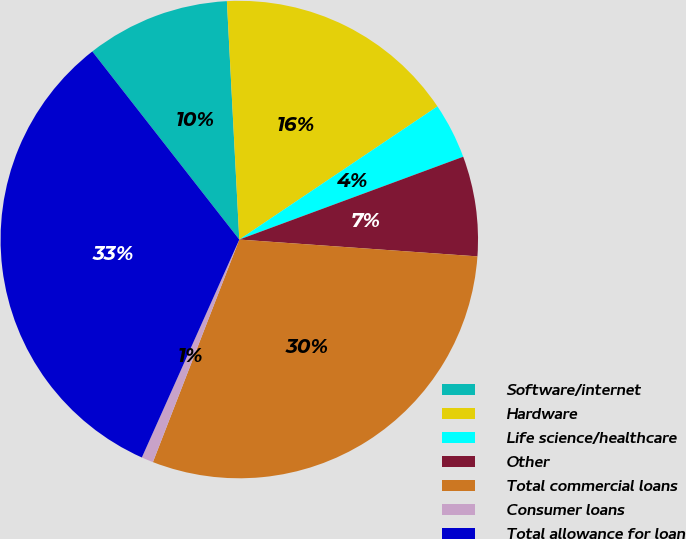<chart> <loc_0><loc_0><loc_500><loc_500><pie_chart><fcel>Software/internet<fcel>Hardware<fcel>Life science/healthcare<fcel>Other<fcel>Total commercial loans<fcel>Consumer loans<fcel>Total allowance for loan<nl><fcel>9.73%<fcel>16.41%<fcel>3.78%<fcel>6.76%<fcel>29.77%<fcel>0.8%<fcel>32.75%<nl></chart> 